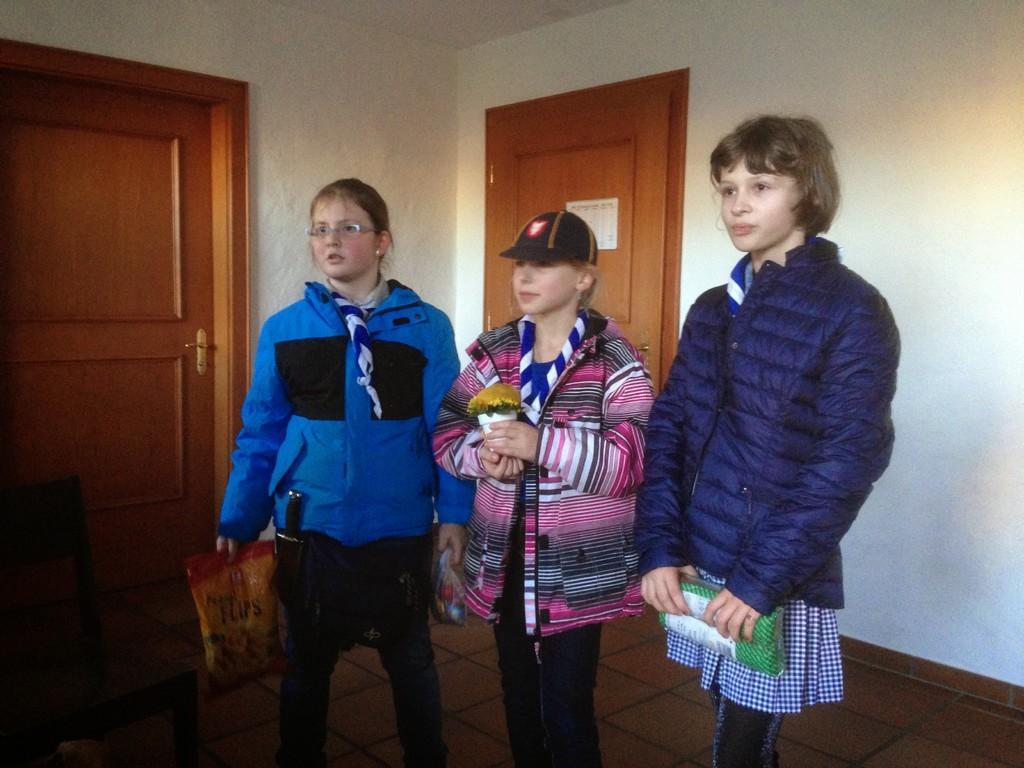Could you give a brief overview of what you see in this image? In this I can see three girls, middle girl holding a flower pot which is contain flower, on the right side girl holding a gift packet, on the left side girl holding a cover,behind them there is a wall and door and on the left side there a door, chair visible. 